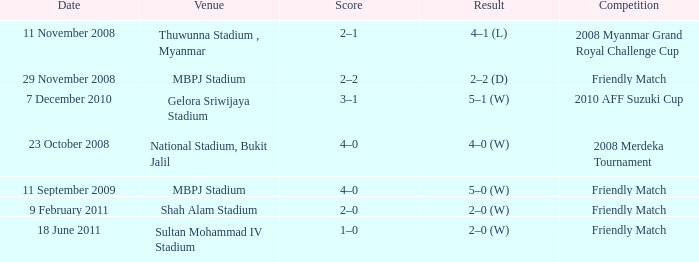What is the Venue of the Competition with a Result of 2–2 (d)? MBPJ Stadium. 